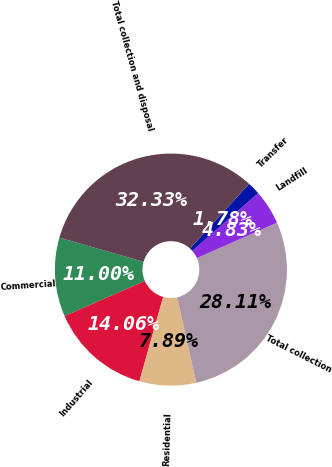Convert chart. <chart><loc_0><loc_0><loc_500><loc_500><pie_chart><fcel>Commercial<fcel>Industrial<fcel>Residential<fcel>Total collection<fcel>Landfill<fcel>Transfer<fcel>Total collection and disposal<nl><fcel>11.0%<fcel>14.06%<fcel>7.89%<fcel>28.11%<fcel>4.83%<fcel>1.78%<fcel>32.33%<nl></chart> 